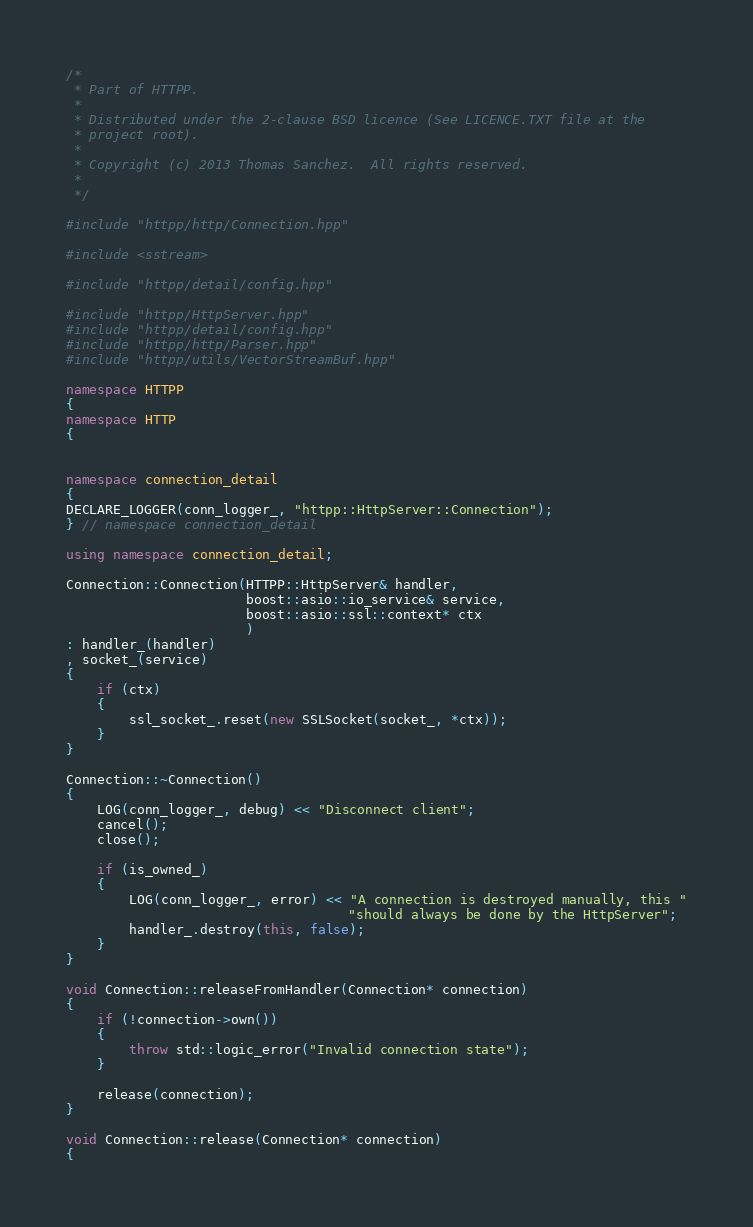<code> <loc_0><loc_0><loc_500><loc_500><_C++_>/*
 * Part of HTTPP.
 *
 * Distributed under the 2-clause BSD licence (See LICENCE.TXT file at the
 * project root).
 *
 * Copyright (c) 2013 Thomas Sanchez.  All rights reserved.
 *
 */

#include "httpp/http/Connection.hpp"

#include <sstream>

#include "httpp/detail/config.hpp"

#include "httpp/HttpServer.hpp"
#include "httpp/detail/config.hpp"
#include "httpp/http/Parser.hpp"
#include "httpp/utils/VectorStreamBuf.hpp"

namespace HTTPP
{
namespace HTTP
{


namespace connection_detail
{
DECLARE_LOGGER(conn_logger_, "httpp::HttpServer::Connection");
} // namespace connection_detail

using namespace connection_detail;

Connection::Connection(HTTPP::HttpServer& handler,
                       boost::asio::io_service& service,
                       boost::asio::ssl::context* ctx
                       )
: handler_(handler)
, socket_(service)
{
    if (ctx)
    {
        ssl_socket_.reset(new SSLSocket(socket_, *ctx));
    }
}

Connection::~Connection()
{
    LOG(conn_logger_, debug) << "Disconnect client";
    cancel();
    close();

    if (is_owned_)
    {
        LOG(conn_logger_, error) << "A connection is destroyed manually, this "
                                    "should always be done by the HttpServer";
        handler_.destroy(this, false);
    }
}

void Connection::releaseFromHandler(Connection* connection)
{
    if (!connection->own())
    {
        throw std::logic_error("Invalid connection state");
    }

    release(connection);
}

void Connection::release(Connection* connection)
{</code> 